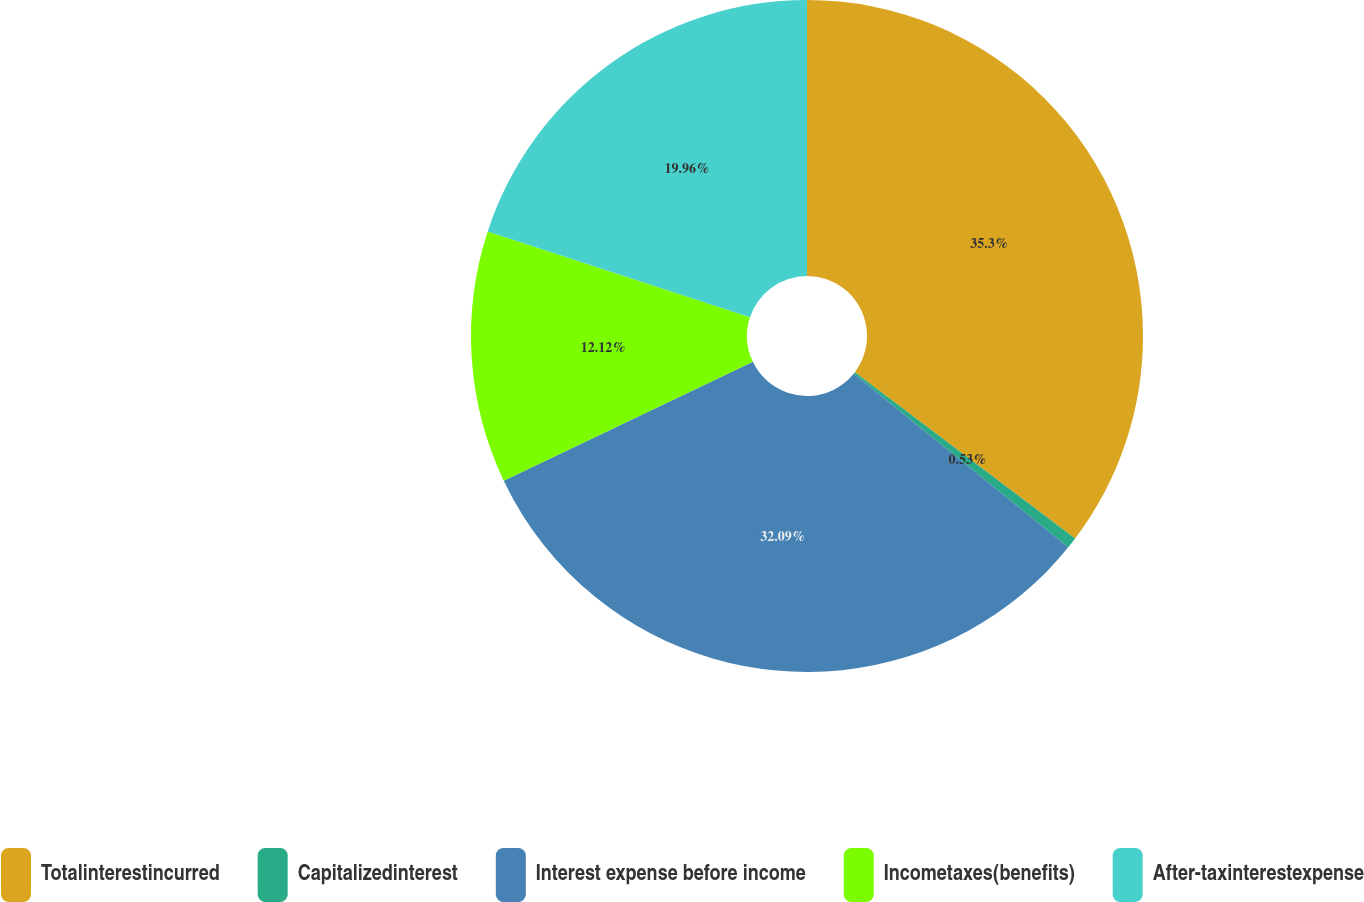Convert chart to OTSL. <chart><loc_0><loc_0><loc_500><loc_500><pie_chart><fcel>Totalinterestincurred<fcel>Capitalizedinterest<fcel>Interest expense before income<fcel>Incometaxes(benefits)<fcel>After-taxinterestexpense<nl><fcel>35.29%<fcel>0.53%<fcel>32.09%<fcel>12.12%<fcel>19.96%<nl></chart> 